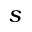<formula> <loc_0><loc_0><loc_500><loc_500>s</formula> 